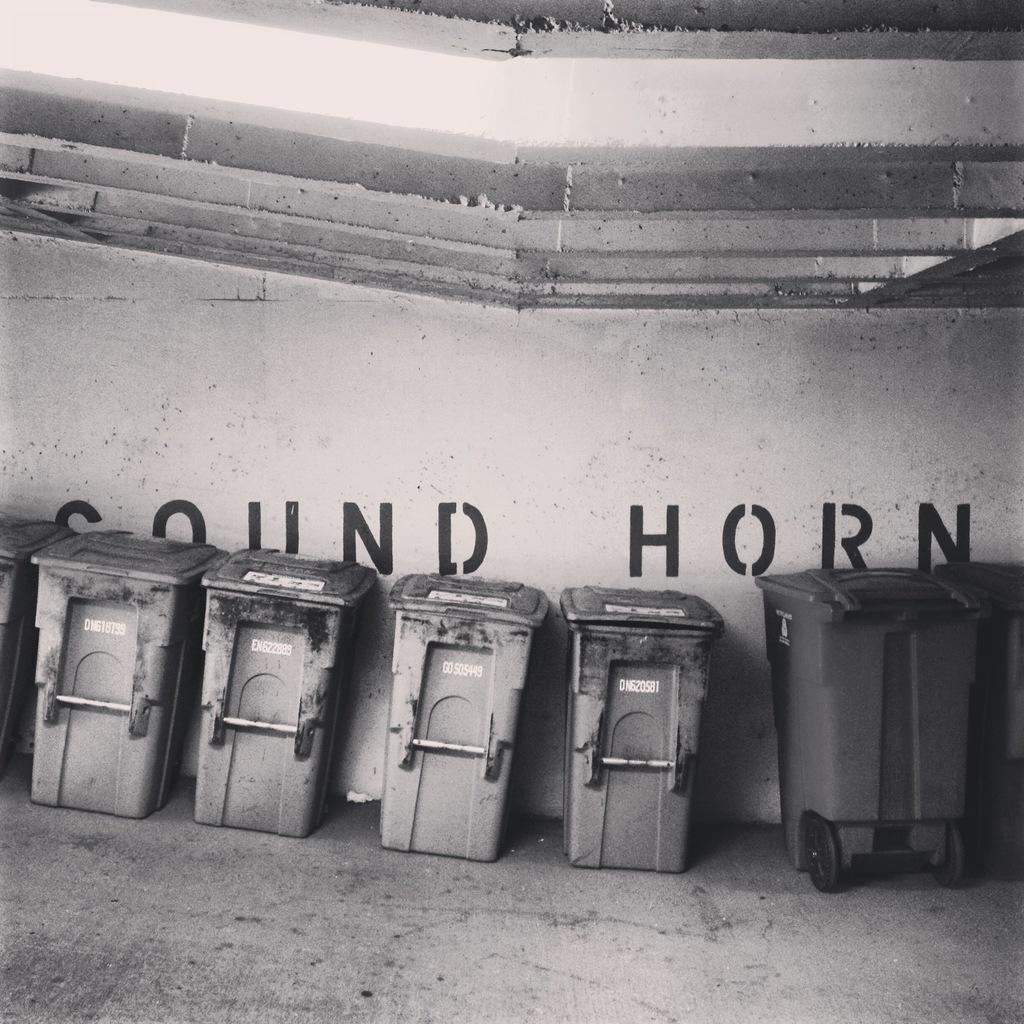<image>
Render a clear and concise summary of the photo. A wall says "sound horn" and has several trash bins lined up along it. 